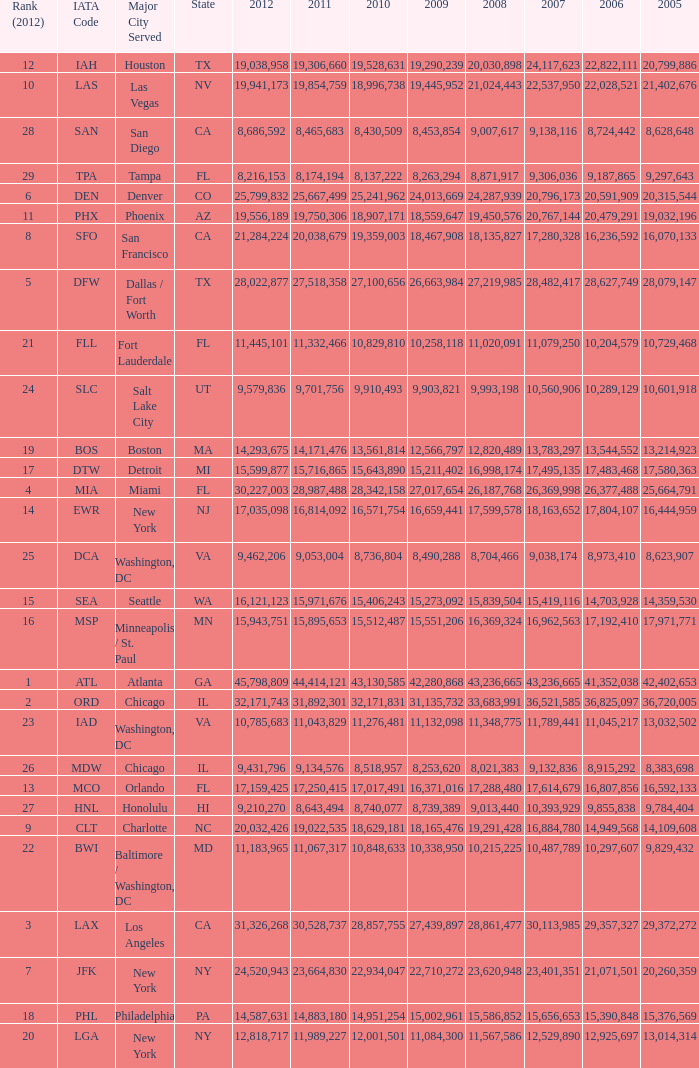For the IATA code of lax with 2009 less than 31,135,732 and 2011 less than 8,174,194, what is the sum of 2012? 0.0. 